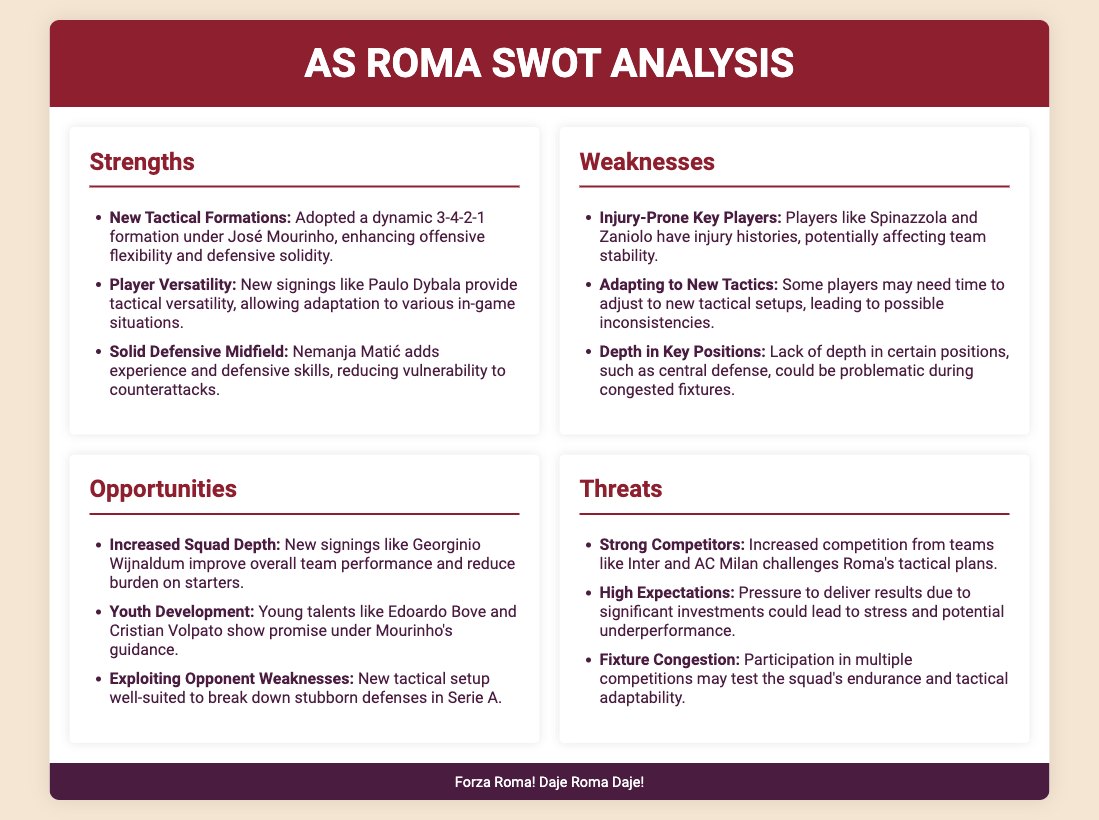what formation has AS Roma adopted? The document mentions that AS Roma has adopted a dynamic 3-4-2-1 formation under José Mourinho.
Answer: 3-4-2-1 who is a key new signing that provides tactical versatility? The document states that new signing Paulo Dybala provides tactical versatility.
Answer: Paulo Dybala what is a specific concern regarding player injuries? The document notes that players like Spinazzola and Zaniolo have injury histories, which could affect team stability.
Answer: Injury histories what is a noted opportunity for the team this season? The document highlights increased squad depth from new signings like Georginio Wijnaldum as an opportunity.
Answer: Increased squad depth name one strong competitor mentioned in the threats section. The document lists teams like Inter and AC Milan as strong competitors.
Answer: Inter how has the squad addressed the issue of depth? The SWOT analysis indicates that new signings like Georginio Wijnaldum improve overall team performance and reduce burden on starters, addressing depth concerns.
Answer: New signings what effect could fixture congestion have on AS Roma? The document points out that fixture congestion may test the squad's endurance and tactical adaptability.
Answer: Endurance and tactical adaptability what is a weakness related to adapting to new tactics? The document mentions that some players may need time to adjust to new tactical setups, leading to possible inconsistencies.
Answer: Possible inconsistencies 